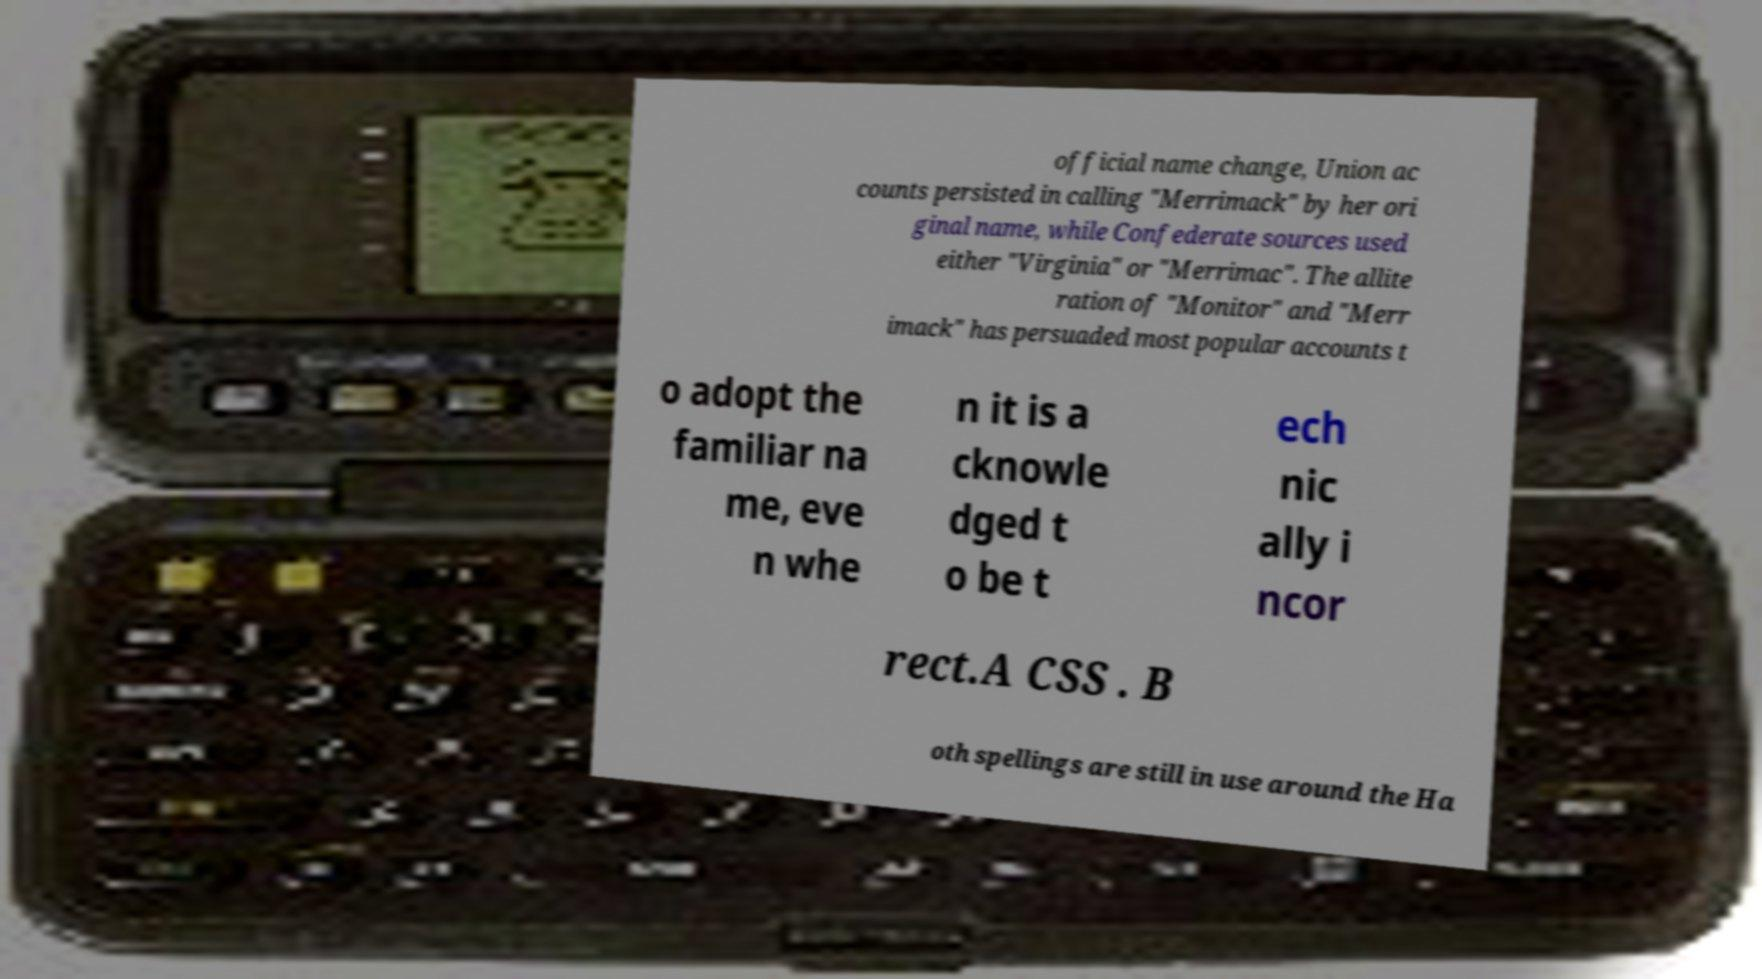Could you assist in decoding the text presented in this image and type it out clearly? official name change, Union ac counts persisted in calling "Merrimack" by her ori ginal name, while Confederate sources used either "Virginia" or "Merrimac". The allite ration of "Monitor" and "Merr imack" has persuaded most popular accounts t o adopt the familiar na me, eve n whe n it is a cknowle dged t o be t ech nic ally i ncor rect.A CSS . B oth spellings are still in use around the Ha 